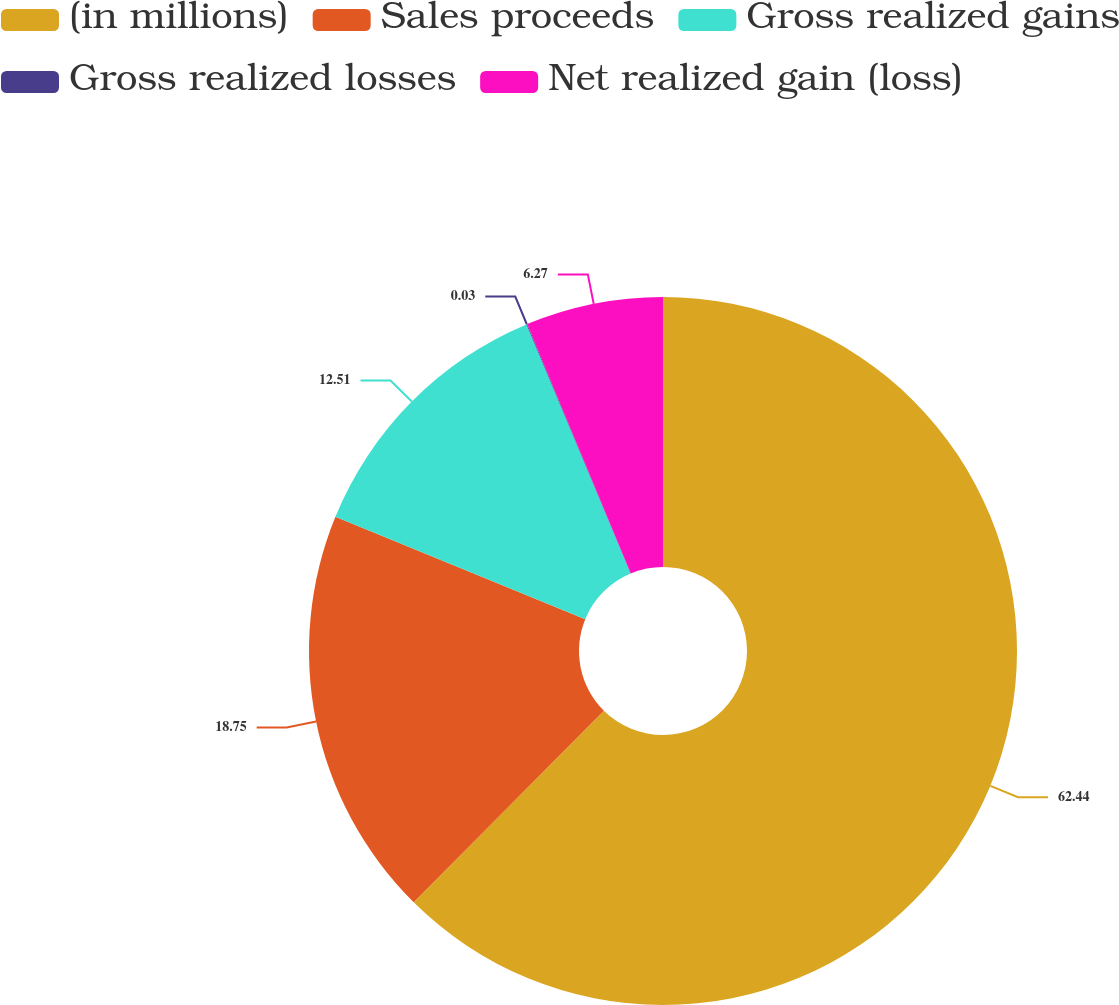Convert chart. <chart><loc_0><loc_0><loc_500><loc_500><pie_chart><fcel>(in millions)<fcel>Sales proceeds<fcel>Gross realized gains<fcel>Gross realized losses<fcel>Net realized gain (loss)<nl><fcel>62.43%<fcel>18.75%<fcel>12.51%<fcel>0.03%<fcel>6.27%<nl></chart> 